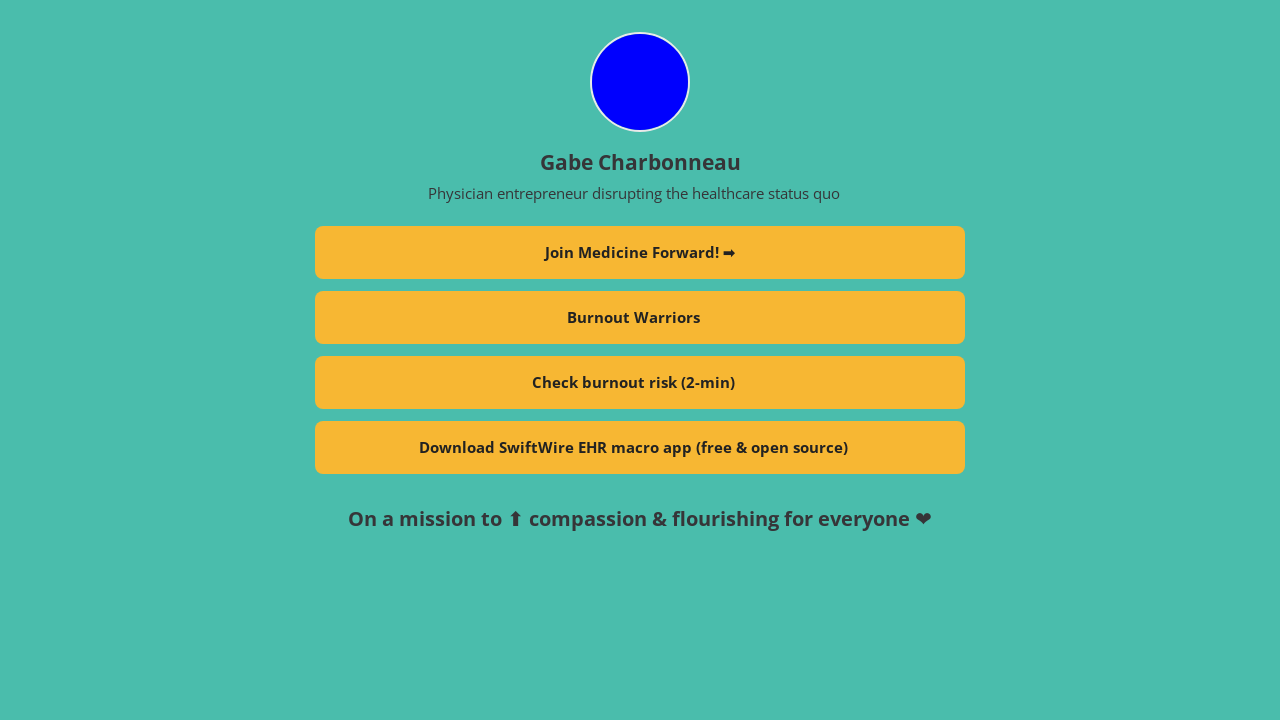How can I start building this website with HTML from the ground up? To begin building a website with HTML from the ground up, start by creating a basic HTML document structure. This includes declaring the document type, defining the HTML element, and adding essential sections like head and body. Here’s a simple template:

<!DOCTYPE html>
<html>
<head>
    <title>Your Website Title</title>
</head>
<body>
    <h1>Welcome to My Website</h1>
    <p>This is a paragraph to start off your webpage.</p>
</body>
</html>

This template sets up a basic webpage with a title, header, and paragraph. From here, you can expand by adding more HTML elements and attributes to define links, images, lists, etc. 